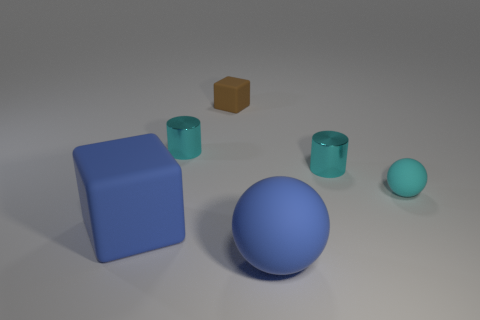What color is the rubber thing that is in front of the blue matte block?
Make the answer very short. Blue. There is a brown cube left of the blue matte sphere; does it have the same size as the blue rubber sphere?
Give a very brief answer. No. What is the size of the blue thing that is the same shape as the tiny brown object?
Keep it short and to the point. Large. Are there any other things that are the same size as the brown matte object?
Your answer should be compact. Yes. Do the tiny brown matte thing and the tiny cyan matte object have the same shape?
Your answer should be very brief. No. Are there fewer rubber blocks behind the tiny matte cube than blue things to the right of the cyan matte sphere?
Your response must be concise. No. What number of large rubber cubes are in front of the large block?
Make the answer very short. 0. Does the large rubber thing in front of the blue rubber cube have the same shape as the large matte thing that is left of the small brown object?
Offer a terse response. No. How many other things are the same color as the tiny matte block?
Offer a terse response. 0. What is the ball that is in front of the tiny object right of the small cyan metallic object that is on the right side of the brown matte cube made of?
Give a very brief answer. Rubber. 